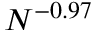<formula> <loc_0><loc_0><loc_500><loc_500>N ^ { - 0 . 9 7 }</formula> 